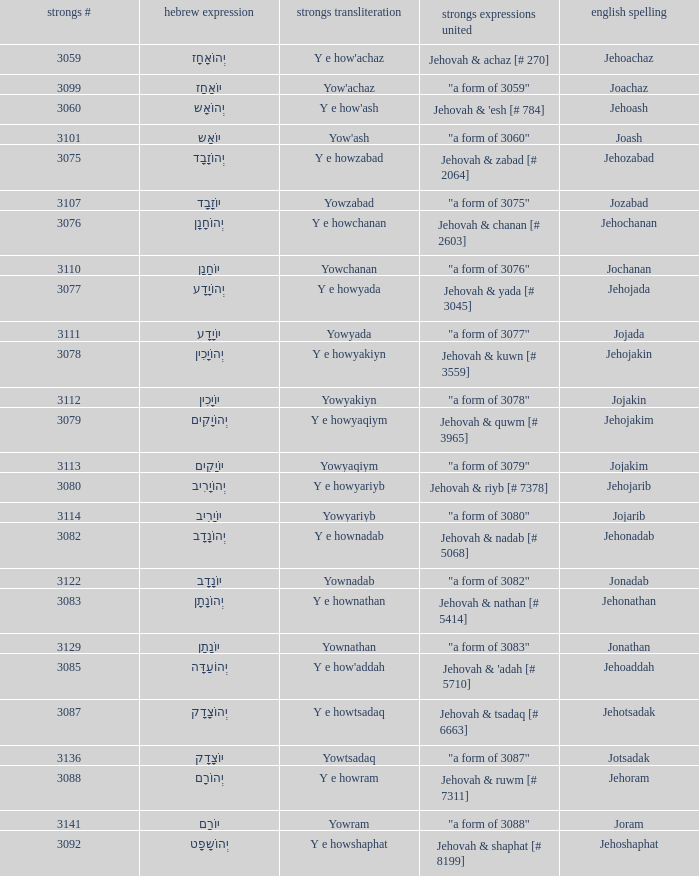What is the strongs words compounded when the english spelling is jonadab? "a form of 3082". 